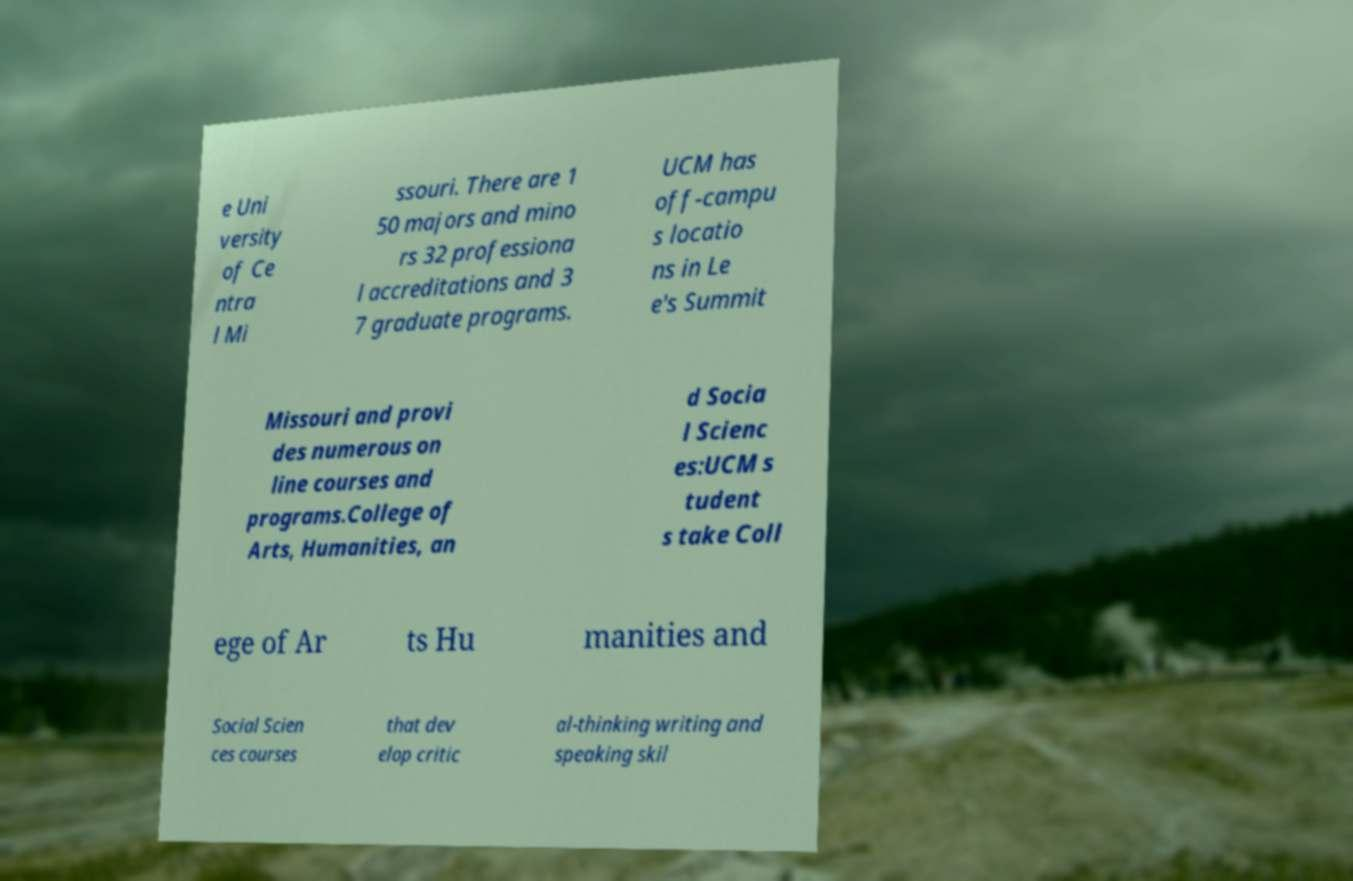Please identify and transcribe the text found in this image. e Uni versity of Ce ntra l Mi ssouri. There are 1 50 majors and mino rs 32 professiona l accreditations and 3 7 graduate programs. UCM has off-campu s locatio ns in Le e's Summit Missouri and provi des numerous on line courses and programs.College of Arts, Humanities, an d Socia l Scienc es:UCM s tudent s take Coll ege of Ar ts Hu manities and Social Scien ces courses that dev elop critic al-thinking writing and speaking skil 